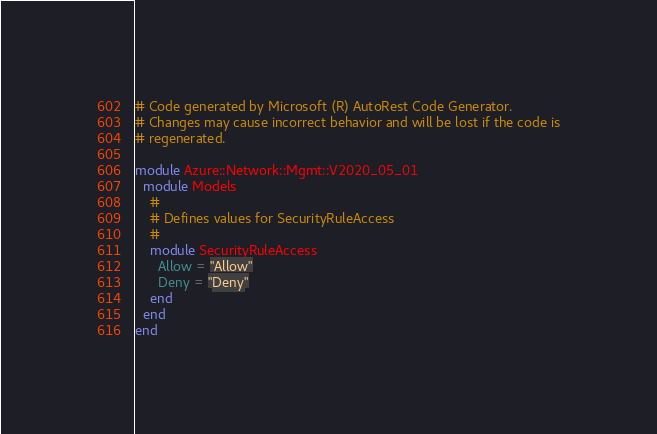<code> <loc_0><loc_0><loc_500><loc_500><_Ruby_># Code generated by Microsoft (R) AutoRest Code Generator.
# Changes may cause incorrect behavior and will be lost if the code is
# regenerated.

module Azure::Network::Mgmt::V2020_05_01
  module Models
    #
    # Defines values for SecurityRuleAccess
    #
    module SecurityRuleAccess
      Allow = "Allow"
      Deny = "Deny"
    end
  end
end
</code> 